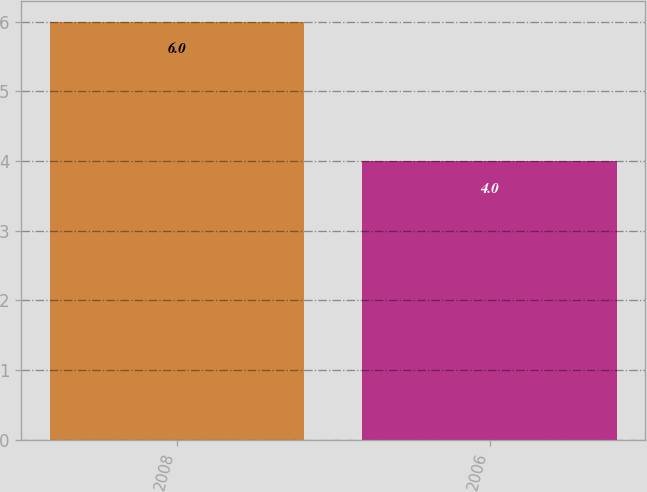Convert chart to OTSL. <chart><loc_0><loc_0><loc_500><loc_500><bar_chart><fcel>2008<fcel>2006<nl><fcel>6<fcel>4<nl></chart> 